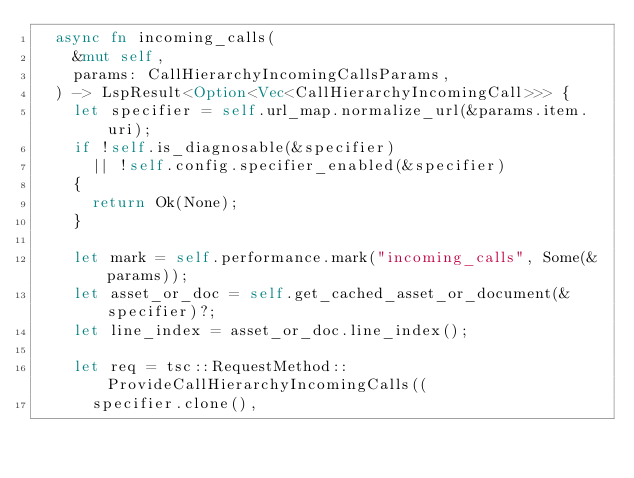Convert code to text. <code><loc_0><loc_0><loc_500><loc_500><_Rust_>  async fn incoming_calls(
    &mut self,
    params: CallHierarchyIncomingCallsParams,
  ) -> LspResult<Option<Vec<CallHierarchyIncomingCall>>> {
    let specifier = self.url_map.normalize_url(&params.item.uri);
    if !self.is_diagnosable(&specifier)
      || !self.config.specifier_enabled(&specifier)
    {
      return Ok(None);
    }

    let mark = self.performance.mark("incoming_calls", Some(&params));
    let asset_or_doc = self.get_cached_asset_or_document(&specifier)?;
    let line_index = asset_or_doc.line_index();

    let req = tsc::RequestMethod::ProvideCallHierarchyIncomingCalls((
      specifier.clone(),</code> 